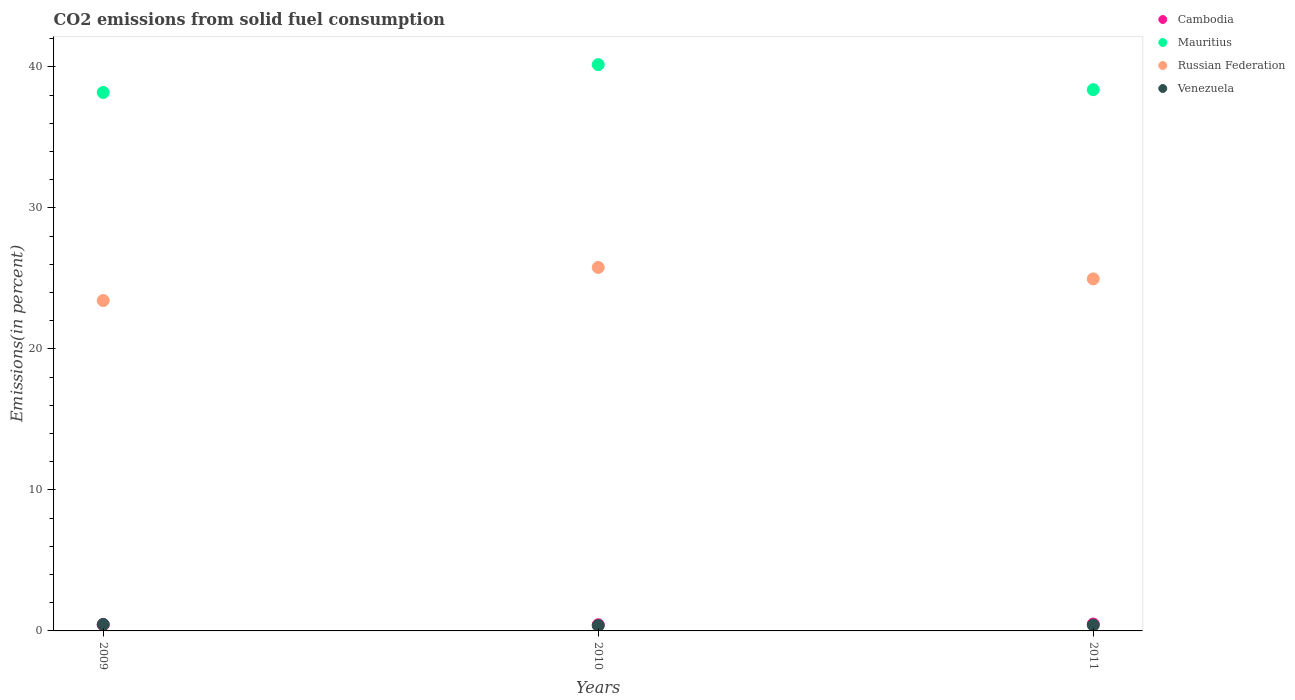What is the total CO2 emitted in Cambodia in 2010?
Your response must be concise. 0.44. Across all years, what is the maximum total CO2 emitted in Venezuela?
Offer a very short reply. 0.46. Across all years, what is the minimum total CO2 emitted in Mauritius?
Offer a terse response. 38.19. In which year was the total CO2 emitted in Russian Federation minimum?
Your response must be concise. 2009. What is the total total CO2 emitted in Cambodia in the graph?
Give a very brief answer. 1.37. What is the difference between the total CO2 emitted in Mauritius in 2009 and that in 2010?
Your response must be concise. -1.97. What is the difference between the total CO2 emitted in Russian Federation in 2011 and the total CO2 emitted in Cambodia in 2010?
Keep it short and to the point. 24.53. What is the average total CO2 emitted in Venezuela per year?
Make the answer very short. 0.42. In the year 2010, what is the difference between the total CO2 emitted in Mauritius and total CO2 emitted in Cambodia?
Give a very brief answer. 39.73. What is the ratio of the total CO2 emitted in Mauritius in 2009 to that in 2011?
Provide a short and direct response. 0.99. What is the difference between the highest and the second highest total CO2 emitted in Mauritius?
Keep it short and to the point. 1.78. What is the difference between the highest and the lowest total CO2 emitted in Russian Federation?
Ensure brevity in your answer.  2.35. Does the graph contain any zero values?
Your answer should be very brief. No. How many legend labels are there?
Provide a succinct answer. 4. How are the legend labels stacked?
Offer a terse response. Vertical. What is the title of the graph?
Make the answer very short. CO2 emissions from solid fuel consumption. What is the label or title of the X-axis?
Provide a short and direct response. Years. What is the label or title of the Y-axis?
Your answer should be very brief. Emissions(in percent). What is the Emissions(in percent) in Cambodia in 2009?
Offer a terse response. 0.44. What is the Emissions(in percent) of Mauritius in 2009?
Provide a short and direct response. 38.19. What is the Emissions(in percent) in Russian Federation in 2009?
Ensure brevity in your answer.  23.43. What is the Emissions(in percent) in Venezuela in 2009?
Ensure brevity in your answer.  0.46. What is the Emissions(in percent) in Cambodia in 2010?
Your answer should be very brief. 0.44. What is the Emissions(in percent) of Mauritius in 2010?
Make the answer very short. 40.17. What is the Emissions(in percent) of Russian Federation in 2010?
Make the answer very short. 25.78. What is the Emissions(in percent) in Venezuela in 2010?
Your answer should be compact. 0.38. What is the Emissions(in percent) of Cambodia in 2011?
Provide a short and direct response. 0.49. What is the Emissions(in percent) in Mauritius in 2011?
Ensure brevity in your answer.  38.39. What is the Emissions(in percent) in Russian Federation in 2011?
Your answer should be compact. 24.97. What is the Emissions(in percent) of Venezuela in 2011?
Offer a terse response. 0.41. Across all years, what is the maximum Emissions(in percent) of Cambodia?
Keep it short and to the point. 0.49. Across all years, what is the maximum Emissions(in percent) in Mauritius?
Ensure brevity in your answer.  40.17. Across all years, what is the maximum Emissions(in percent) of Russian Federation?
Give a very brief answer. 25.78. Across all years, what is the maximum Emissions(in percent) in Venezuela?
Your answer should be very brief. 0.46. Across all years, what is the minimum Emissions(in percent) in Cambodia?
Provide a short and direct response. 0.44. Across all years, what is the minimum Emissions(in percent) in Mauritius?
Keep it short and to the point. 38.19. Across all years, what is the minimum Emissions(in percent) in Russian Federation?
Your response must be concise. 23.43. Across all years, what is the minimum Emissions(in percent) in Venezuela?
Offer a terse response. 0.38. What is the total Emissions(in percent) of Cambodia in the graph?
Give a very brief answer. 1.37. What is the total Emissions(in percent) of Mauritius in the graph?
Offer a very short reply. 116.75. What is the total Emissions(in percent) in Russian Federation in the graph?
Give a very brief answer. 74.19. What is the total Emissions(in percent) in Venezuela in the graph?
Offer a very short reply. 1.26. What is the difference between the Emissions(in percent) of Cambodia in 2009 and that in 2010?
Keep it short and to the point. 0.01. What is the difference between the Emissions(in percent) of Mauritius in 2009 and that in 2010?
Provide a succinct answer. -1.97. What is the difference between the Emissions(in percent) in Russian Federation in 2009 and that in 2010?
Offer a very short reply. -2.35. What is the difference between the Emissions(in percent) of Cambodia in 2009 and that in 2011?
Your answer should be compact. -0.05. What is the difference between the Emissions(in percent) in Mauritius in 2009 and that in 2011?
Your answer should be compact. -0.2. What is the difference between the Emissions(in percent) in Russian Federation in 2009 and that in 2011?
Give a very brief answer. -1.54. What is the difference between the Emissions(in percent) in Venezuela in 2009 and that in 2011?
Offer a very short reply. 0.05. What is the difference between the Emissions(in percent) of Cambodia in 2010 and that in 2011?
Your answer should be compact. -0.05. What is the difference between the Emissions(in percent) in Mauritius in 2010 and that in 2011?
Make the answer very short. 1.78. What is the difference between the Emissions(in percent) of Russian Federation in 2010 and that in 2011?
Give a very brief answer. 0.81. What is the difference between the Emissions(in percent) in Venezuela in 2010 and that in 2011?
Ensure brevity in your answer.  -0.03. What is the difference between the Emissions(in percent) of Cambodia in 2009 and the Emissions(in percent) of Mauritius in 2010?
Offer a very short reply. -39.72. What is the difference between the Emissions(in percent) of Cambodia in 2009 and the Emissions(in percent) of Russian Federation in 2010?
Ensure brevity in your answer.  -25.34. What is the difference between the Emissions(in percent) in Cambodia in 2009 and the Emissions(in percent) in Venezuela in 2010?
Offer a terse response. 0.06. What is the difference between the Emissions(in percent) of Mauritius in 2009 and the Emissions(in percent) of Russian Federation in 2010?
Your answer should be very brief. 12.41. What is the difference between the Emissions(in percent) of Mauritius in 2009 and the Emissions(in percent) of Venezuela in 2010?
Give a very brief answer. 37.81. What is the difference between the Emissions(in percent) in Russian Federation in 2009 and the Emissions(in percent) in Venezuela in 2010?
Provide a short and direct response. 23.05. What is the difference between the Emissions(in percent) in Cambodia in 2009 and the Emissions(in percent) in Mauritius in 2011?
Offer a terse response. -37.95. What is the difference between the Emissions(in percent) in Cambodia in 2009 and the Emissions(in percent) in Russian Federation in 2011?
Keep it short and to the point. -24.53. What is the difference between the Emissions(in percent) of Cambodia in 2009 and the Emissions(in percent) of Venezuela in 2011?
Provide a succinct answer. 0.03. What is the difference between the Emissions(in percent) of Mauritius in 2009 and the Emissions(in percent) of Russian Federation in 2011?
Make the answer very short. 13.22. What is the difference between the Emissions(in percent) of Mauritius in 2009 and the Emissions(in percent) of Venezuela in 2011?
Ensure brevity in your answer.  37.78. What is the difference between the Emissions(in percent) of Russian Federation in 2009 and the Emissions(in percent) of Venezuela in 2011?
Make the answer very short. 23.02. What is the difference between the Emissions(in percent) of Cambodia in 2010 and the Emissions(in percent) of Mauritius in 2011?
Ensure brevity in your answer.  -37.95. What is the difference between the Emissions(in percent) in Cambodia in 2010 and the Emissions(in percent) in Russian Federation in 2011?
Provide a succinct answer. -24.53. What is the difference between the Emissions(in percent) in Cambodia in 2010 and the Emissions(in percent) in Venezuela in 2011?
Your response must be concise. 0.03. What is the difference between the Emissions(in percent) of Mauritius in 2010 and the Emissions(in percent) of Russian Federation in 2011?
Your response must be concise. 15.2. What is the difference between the Emissions(in percent) in Mauritius in 2010 and the Emissions(in percent) in Venezuela in 2011?
Give a very brief answer. 39.76. What is the difference between the Emissions(in percent) of Russian Federation in 2010 and the Emissions(in percent) of Venezuela in 2011?
Ensure brevity in your answer.  25.37. What is the average Emissions(in percent) in Cambodia per year?
Offer a very short reply. 0.46. What is the average Emissions(in percent) in Mauritius per year?
Provide a short and direct response. 38.92. What is the average Emissions(in percent) in Russian Federation per year?
Provide a short and direct response. 24.73. What is the average Emissions(in percent) in Venezuela per year?
Offer a terse response. 0.42. In the year 2009, what is the difference between the Emissions(in percent) in Cambodia and Emissions(in percent) in Mauritius?
Provide a short and direct response. -37.75. In the year 2009, what is the difference between the Emissions(in percent) of Cambodia and Emissions(in percent) of Russian Federation?
Offer a very short reply. -22.99. In the year 2009, what is the difference between the Emissions(in percent) of Cambodia and Emissions(in percent) of Venezuela?
Keep it short and to the point. -0.02. In the year 2009, what is the difference between the Emissions(in percent) in Mauritius and Emissions(in percent) in Russian Federation?
Your answer should be very brief. 14.76. In the year 2009, what is the difference between the Emissions(in percent) of Mauritius and Emissions(in percent) of Venezuela?
Offer a very short reply. 37.73. In the year 2009, what is the difference between the Emissions(in percent) in Russian Federation and Emissions(in percent) in Venezuela?
Keep it short and to the point. 22.97. In the year 2010, what is the difference between the Emissions(in percent) of Cambodia and Emissions(in percent) of Mauritius?
Your answer should be very brief. -39.73. In the year 2010, what is the difference between the Emissions(in percent) of Cambodia and Emissions(in percent) of Russian Federation?
Keep it short and to the point. -25.35. In the year 2010, what is the difference between the Emissions(in percent) of Cambodia and Emissions(in percent) of Venezuela?
Offer a very short reply. 0.06. In the year 2010, what is the difference between the Emissions(in percent) of Mauritius and Emissions(in percent) of Russian Federation?
Provide a short and direct response. 14.39. In the year 2010, what is the difference between the Emissions(in percent) in Mauritius and Emissions(in percent) in Venezuela?
Your answer should be very brief. 39.79. In the year 2010, what is the difference between the Emissions(in percent) in Russian Federation and Emissions(in percent) in Venezuela?
Give a very brief answer. 25.4. In the year 2011, what is the difference between the Emissions(in percent) of Cambodia and Emissions(in percent) of Mauritius?
Provide a short and direct response. -37.9. In the year 2011, what is the difference between the Emissions(in percent) of Cambodia and Emissions(in percent) of Russian Federation?
Give a very brief answer. -24.48. In the year 2011, what is the difference between the Emissions(in percent) of Cambodia and Emissions(in percent) of Venezuela?
Provide a succinct answer. 0.08. In the year 2011, what is the difference between the Emissions(in percent) of Mauritius and Emissions(in percent) of Russian Federation?
Provide a succinct answer. 13.42. In the year 2011, what is the difference between the Emissions(in percent) of Mauritius and Emissions(in percent) of Venezuela?
Your answer should be compact. 37.98. In the year 2011, what is the difference between the Emissions(in percent) of Russian Federation and Emissions(in percent) of Venezuela?
Provide a succinct answer. 24.56. What is the ratio of the Emissions(in percent) in Cambodia in 2009 to that in 2010?
Make the answer very short. 1.01. What is the ratio of the Emissions(in percent) in Mauritius in 2009 to that in 2010?
Ensure brevity in your answer.  0.95. What is the ratio of the Emissions(in percent) of Russian Federation in 2009 to that in 2010?
Offer a very short reply. 0.91. What is the ratio of the Emissions(in percent) in Venezuela in 2009 to that in 2010?
Ensure brevity in your answer.  1.21. What is the ratio of the Emissions(in percent) in Cambodia in 2009 to that in 2011?
Give a very brief answer. 0.91. What is the ratio of the Emissions(in percent) in Mauritius in 2009 to that in 2011?
Your answer should be compact. 0.99. What is the ratio of the Emissions(in percent) of Russian Federation in 2009 to that in 2011?
Keep it short and to the point. 0.94. What is the ratio of the Emissions(in percent) of Venezuela in 2009 to that in 2011?
Provide a succinct answer. 1.12. What is the ratio of the Emissions(in percent) of Cambodia in 2010 to that in 2011?
Ensure brevity in your answer.  0.89. What is the ratio of the Emissions(in percent) of Mauritius in 2010 to that in 2011?
Make the answer very short. 1.05. What is the ratio of the Emissions(in percent) of Russian Federation in 2010 to that in 2011?
Make the answer very short. 1.03. What is the ratio of the Emissions(in percent) in Venezuela in 2010 to that in 2011?
Offer a very short reply. 0.93. What is the difference between the highest and the second highest Emissions(in percent) in Cambodia?
Offer a terse response. 0.05. What is the difference between the highest and the second highest Emissions(in percent) of Mauritius?
Ensure brevity in your answer.  1.78. What is the difference between the highest and the second highest Emissions(in percent) in Russian Federation?
Your answer should be compact. 0.81. What is the difference between the highest and the second highest Emissions(in percent) of Venezuela?
Your answer should be very brief. 0.05. What is the difference between the highest and the lowest Emissions(in percent) in Cambodia?
Your answer should be compact. 0.05. What is the difference between the highest and the lowest Emissions(in percent) of Mauritius?
Your response must be concise. 1.97. What is the difference between the highest and the lowest Emissions(in percent) in Russian Federation?
Make the answer very short. 2.35. 